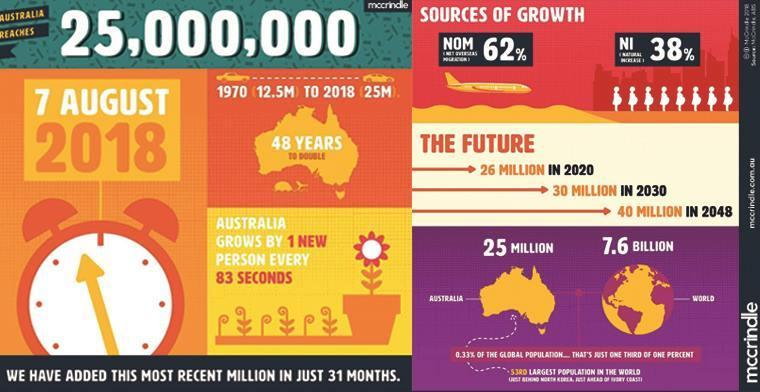How many years did it take for the population of Australia to double from the year 1970?
Answer the question with a short phrase. 48 years What was the world population in 2018? 7.6 billion What was the percentage increase in population due to overseas migration? 62% What was the percentage of growth in population due to natural increase? 38% 